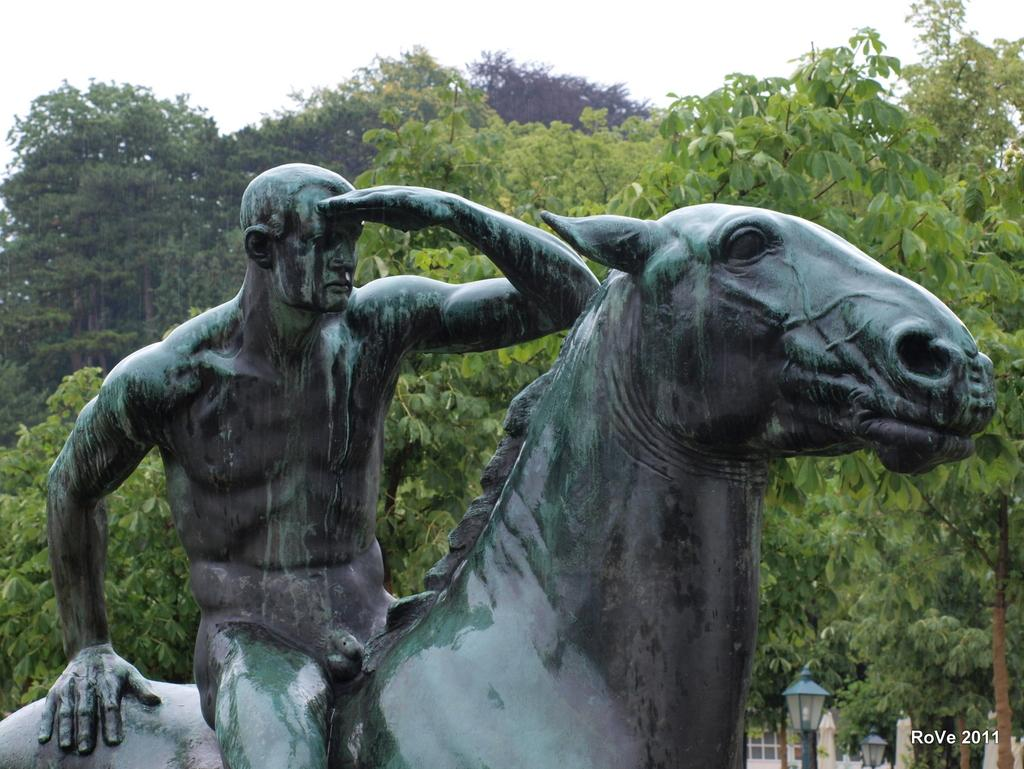What type of scene is depicted in the image? The image is of an outdoor scene. What is the main subject in the center of the image? There is a sculpture of a man and a horse in the center of the image. What can be seen in the background of the image? The sky, trees, and street lamps are visible in the background of the image. What type of hands does the creator of the sculpture have? The creator of the sculpture is not present in the image, so we cannot determine the type of hands they have. 